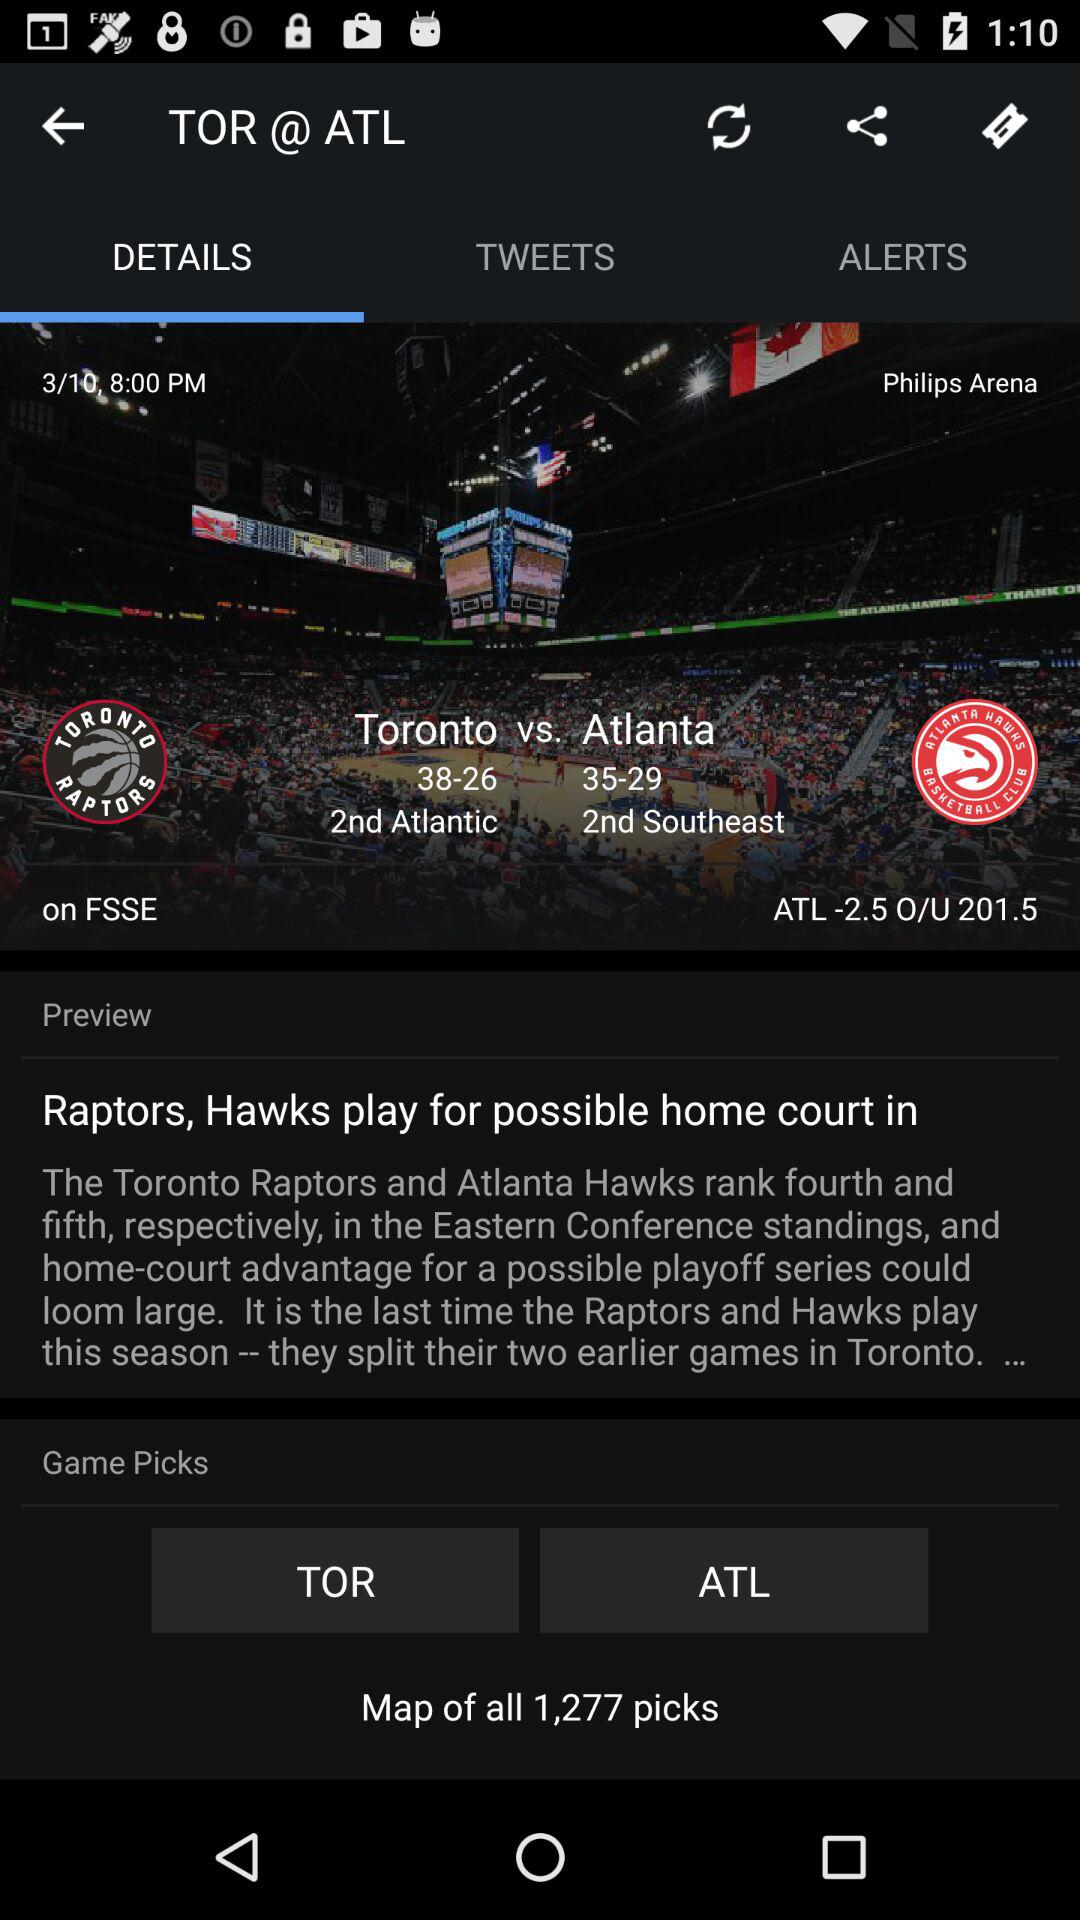What tab is selected? The selected tab is "DETAILS". 